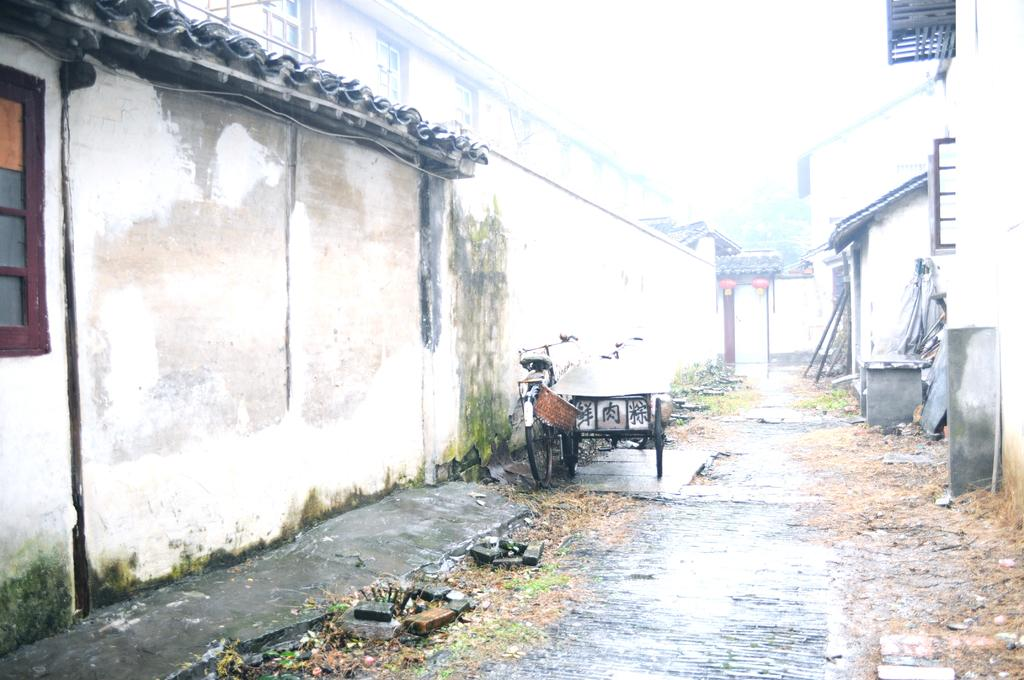What is located behind the bicycle and cart vehicle in the image? There is a wall behind the bicycle and cart vehicle in the image. What type of vehicle is present in front of the wall? There is a cart vehicle in front of the wall. What structure is located on the right side of the image? There is a house on the right side of the image. What is visible at the top of the image? The sky is visible at the top of the image. What type of afterthought is depicted on the wall in the image? There is no afterthought depicted on the wall in the image; it simply shows a wall with a bicycle and cart vehicle in front of it. 